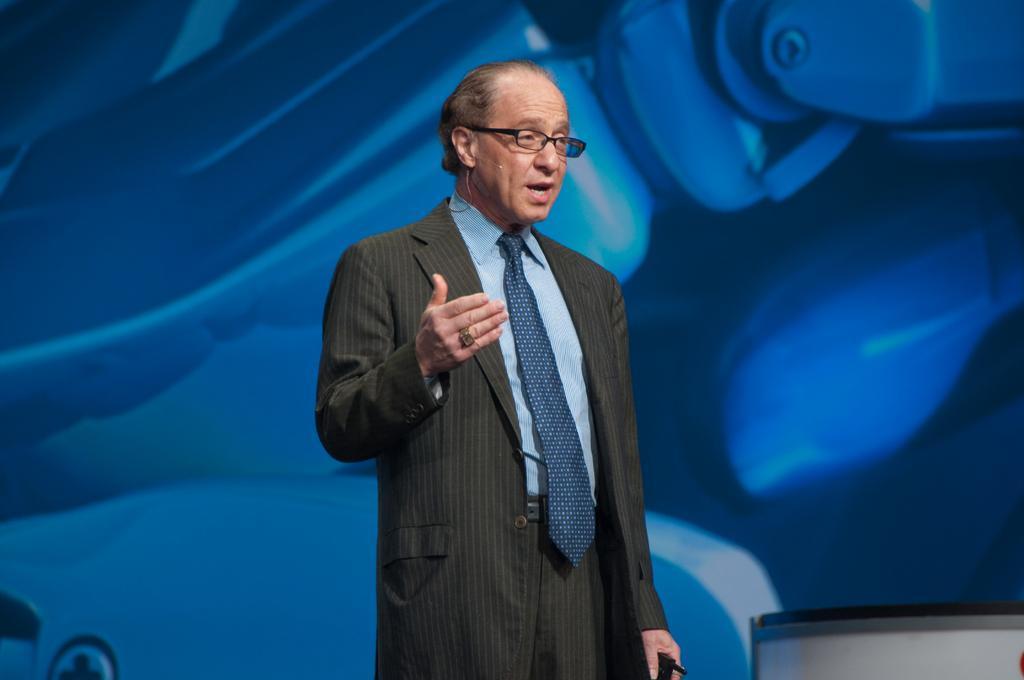How would you summarize this image in a sentence or two? In this image, I can see a person standing. In the background, it looks like a board. In the bottom right corner of the image, I can see an object. 